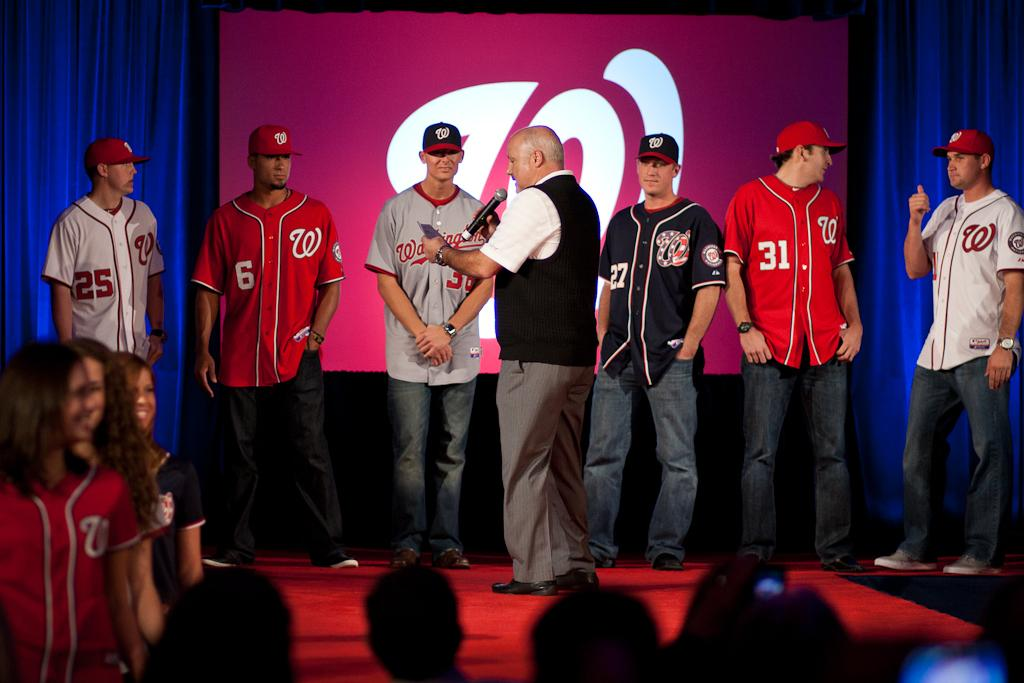<image>
Provide a brief description of the given image. a few guys in Washington Nationals jerseys on the stage 